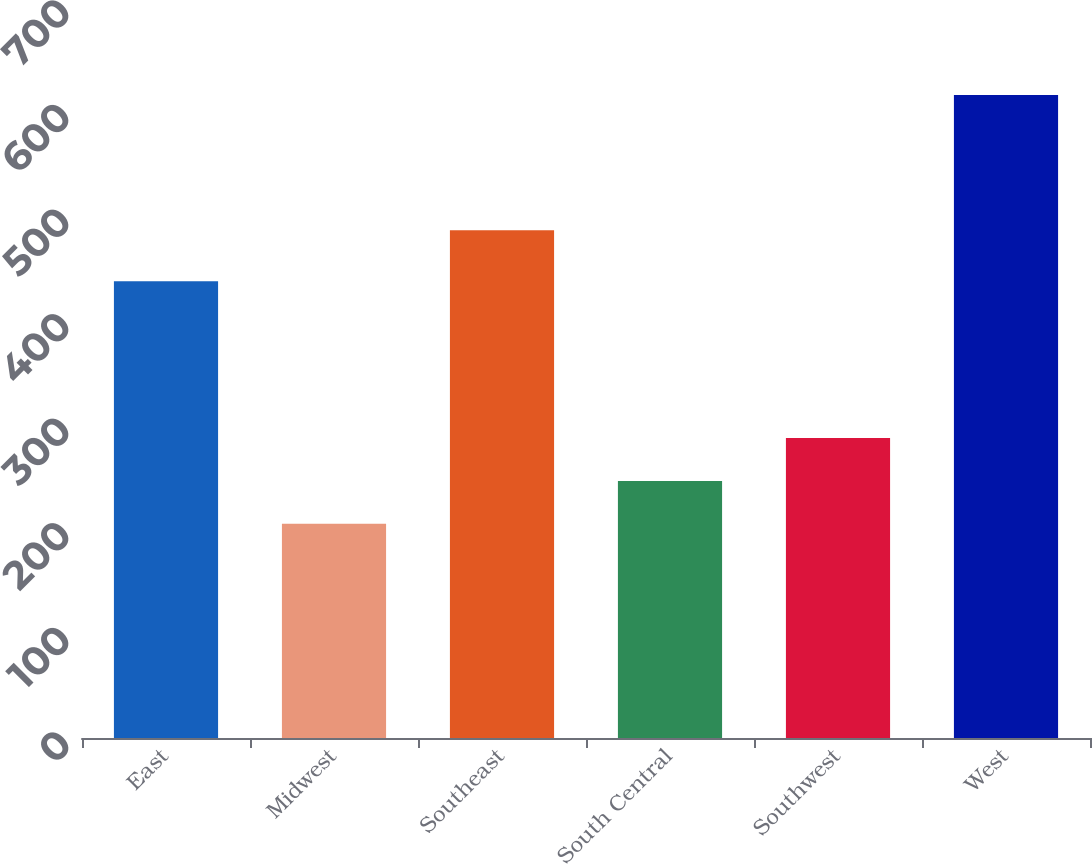Convert chart to OTSL. <chart><loc_0><loc_0><loc_500><loc_500><bar_chart><fcel>East<fcel>Midwest<fcel>Southeast<fcel>South Central<fcel>Southwest<fcel>West<nl><fcel>436.9<fcel>204.8<fcel>485.5<fcel>245.8<fcel>286.8<fcel>614.8<nl></chart> 